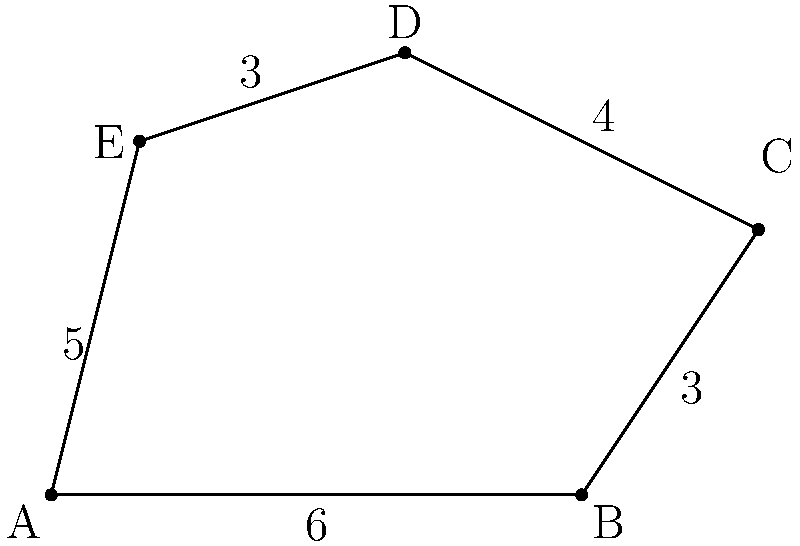A network topology is represented by an irregular pentagon ABCDE. Given that AB = 6 units, BC = 3 units, CD = 4 units, DE = 3 units, and EA = 5 units, calculate the perimeter of the network topology. How would this information be useful in assessing potential vulnerabilities in the network infrastructure? To calculate the perimeter of the irregular pentagon representing the network topology, we need to sum up the lengths of all sides. Here's a step-by-step explanation:

1. Identify the given lengths:
   AB = 6 units
   BC = 3 units
   CD = 4 units
   DE = 3 units
   EA = 5 units

2. Add all the lengths:
   Perimeter = AB + BC + CD + DE + EA
             = 6 + 3 + 4 + 3 + 5
             = 21 units

3. Interpretation for network security:
   The perimeter represents the total external boundary of the network topology. This information is crucial for assessing potential vulnerabilities because:
   
   a) It indicates the total exposure of the network to external threats.
   b) Longer perimeters may require more resources for monitoring and protection.
   c) Each segment of the perimeter might represent different types of connections or security measures, helping prioritize vulnerability assessments.
   d) Understanding the topology's shape and size aids in planning efficient security measures and identifying potential weak points in the network infrastructure.
Answer: 21 units 